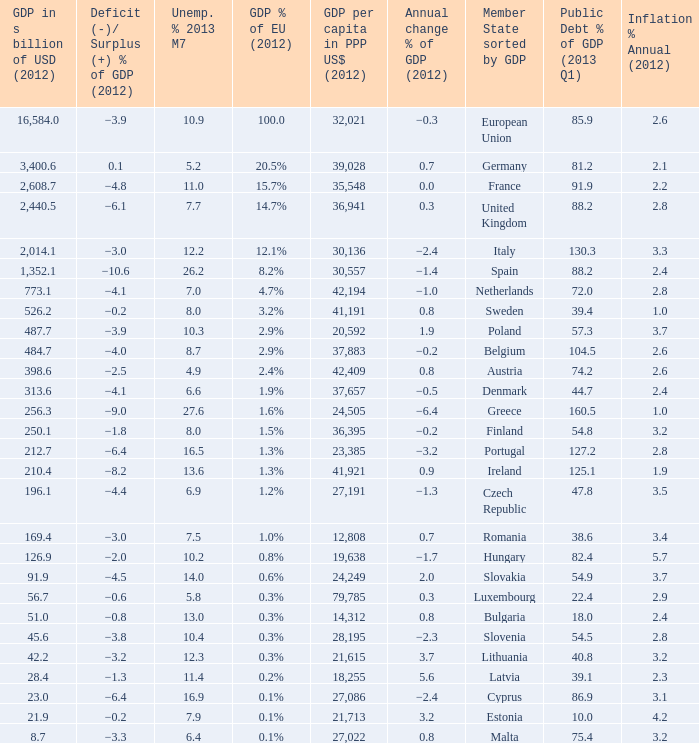What is the deficit/surplus % of the 2012 GDP of the country with a GDP in billions of USD in 2012 less than 1,352.1, a GDP per capita in PPP US dollars in 2012 greater than 21,615, public debt % of GDP in the 2013 Q1 less than 75.4, and an inflation % annual in 2012 of 2.9? −0.6. 